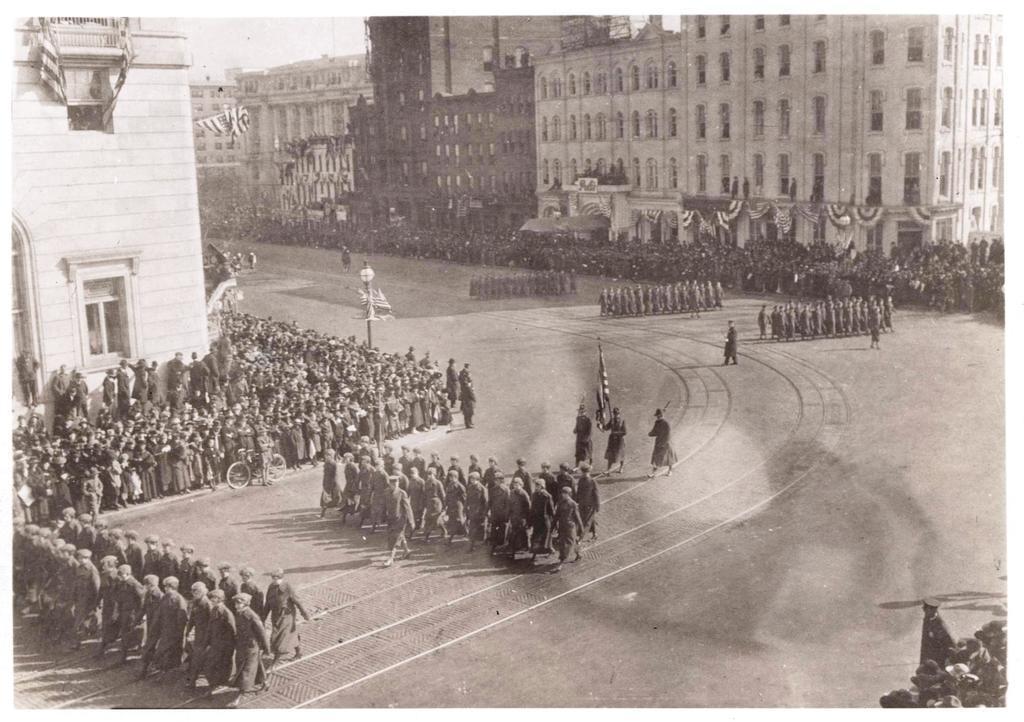Please provide a concise description of this image. It looks like an old black and white picture. We can see a group of people are walking on the road and some people are standing on the path and on the path there is a pole with a light. Behind the people there are buildings and a sky. 